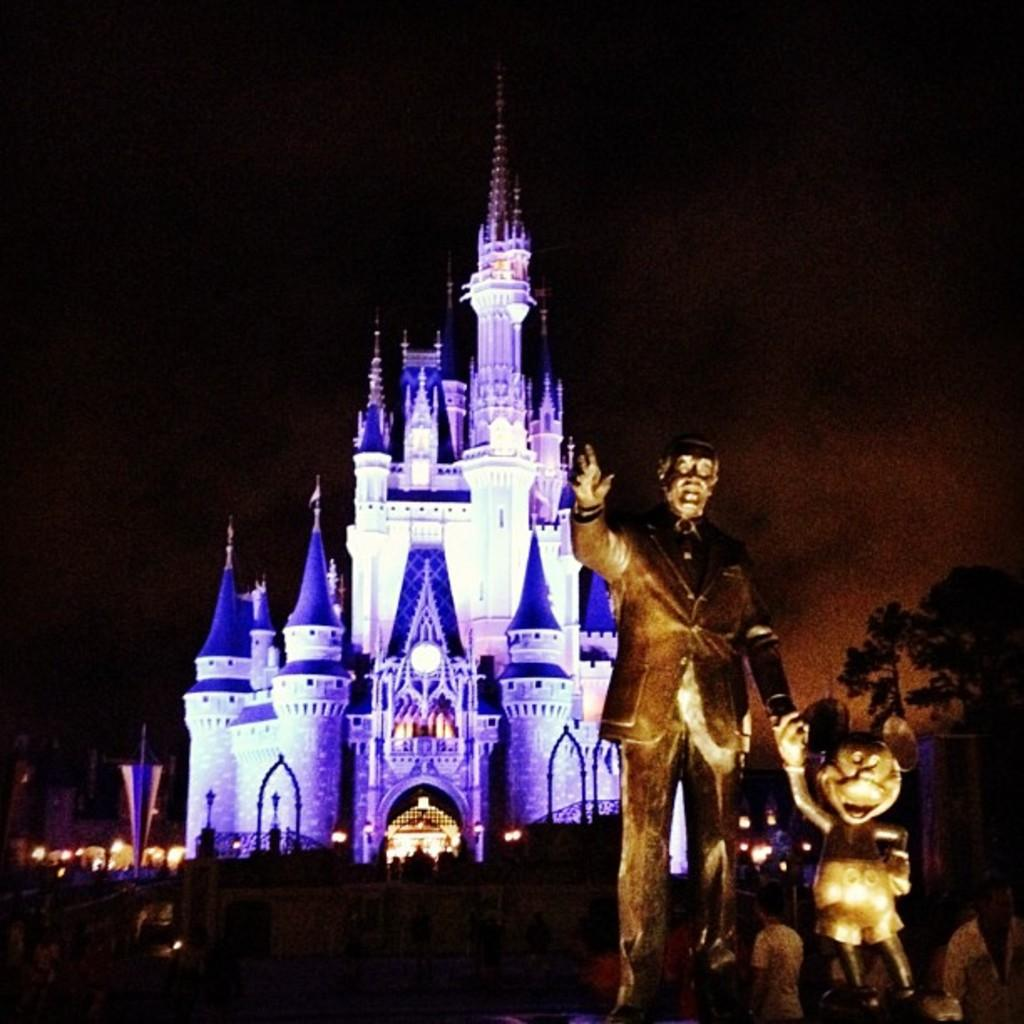What type of structures can be seen on the right side of the image? There are statues on the right side of the image. What famous landmark is visible in the background of the image? There is a Cinderella castle in the background area. What type of natural elements can be seen in the image? There are trees visible in the image. What type of advice can be seen being given by the creature in the image? There is no creature present in the image, so no advice can be seen being given. What is the name of the downtown area visible in the image? The image does not depict a downtown area, so no specific name can be provided. 